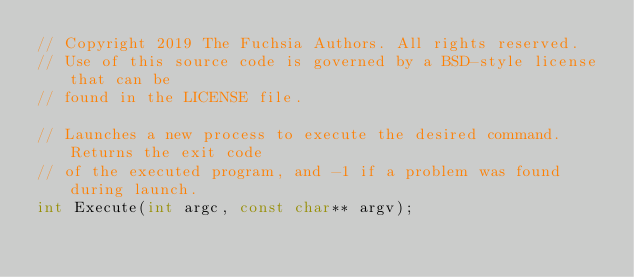Convert code to text. <code><loc_0><loc_0><loc_500><loc_500><_C_>// Copyright 2019 The Fuchsia Authors. All rights reserved.
// Use of this source code is governed by a BSD-style license that can be
// found in the LICENSE file.

// Launches a new process to execute the desired command. Returns the exit code
// of the executed program, and -1 if a problem was found during launch.
int Execute(int argc, const char** argv);
</code> 